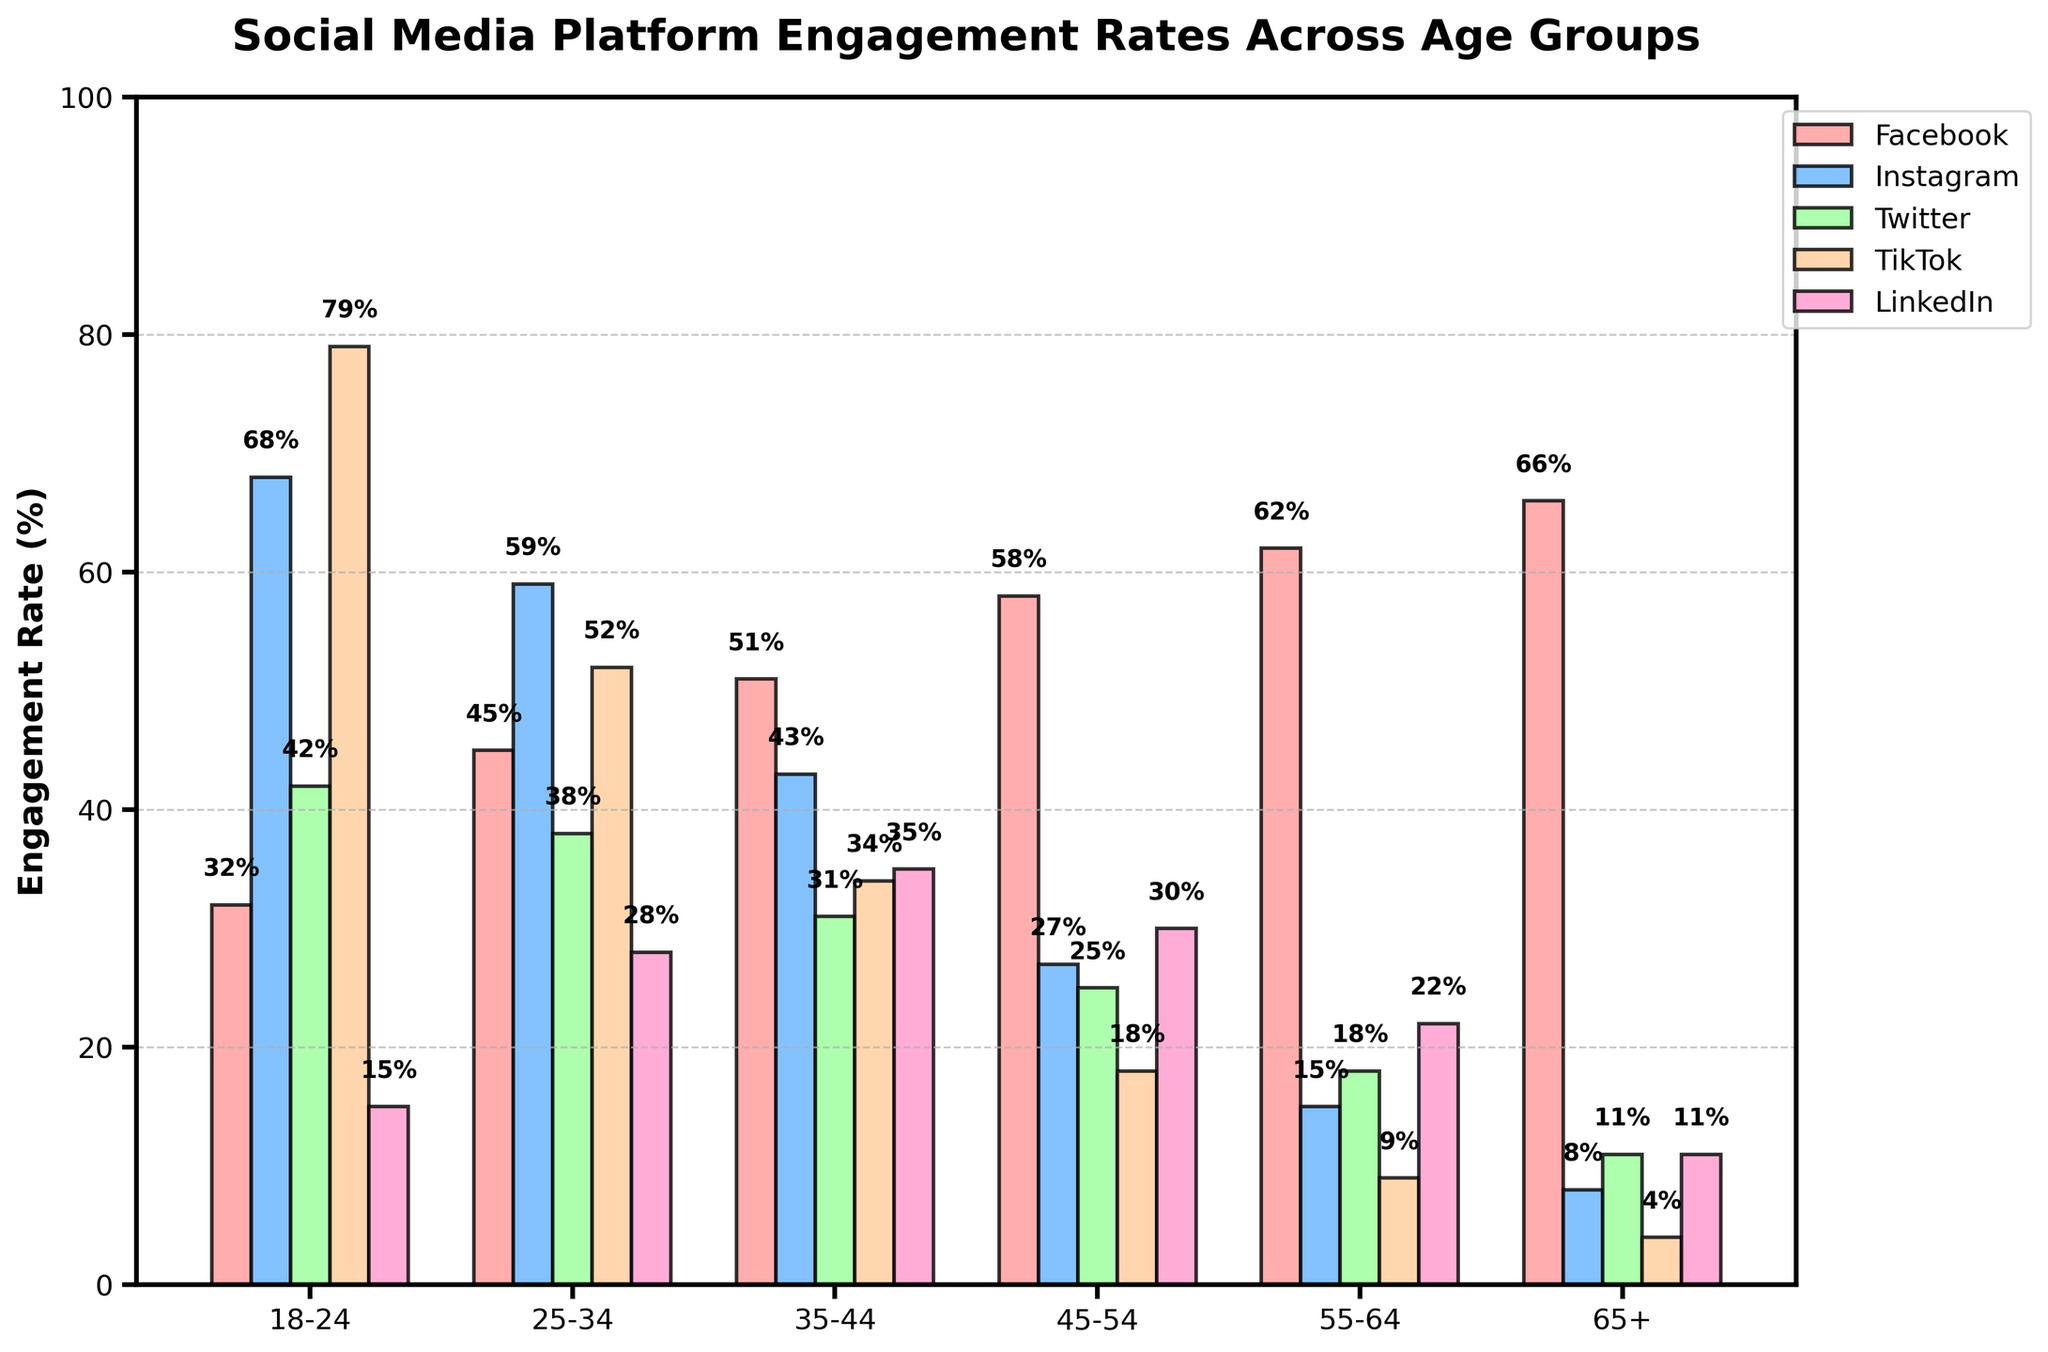What age group has the highest engagement rate on Facebook? The highest bar for Facebook corresponds to the age group 65+, with an engagement rate of 66%.
Answer: 65+ Which social media platform has the lowest engagement rate for the age group 18-24? By looking at the bars for the age group 18-24, LinkedIn has the lowest engagement rate with 15%.
Answer: LinkedIn How much higher is the engagement rate for Instagram than Twitter in the 18-24 age group? The engagement rate for Instagram is 68%, while for Twitter it is 42%. The difference is 68% - 42% = 26%.
Answer: 26% Which age group shows the highest engagement rate on LinkedIn, and what is that rate? The age group with the highest bar for LinkedIn is 35-44, with an engagement rate of 35%.
Answer: 35-44, 35% What's the average engagement rate on TikTok across all age groups? To find the average: (79% + 52% + 34% + 18% + 9% + 4%) / 6 = 32.67%.
Answer: 32.67% For the age group 55-64, which two platforms have the closest engagement rates, and what are those rates? For 55-64, Facebook is 62%, Instagram 15%, Twitter 18%, TikTok 9%, LinkedIn 22%. The closest are Instagram and Twitter (15% and 18%), difference is 3%.
Answer: Instagram and Twitter, 15% and 18% Is the engagement rate for TikTok higher in the 18-24 group or the 25-34 group, and by how much? For the 18-24 group, TikTok has 79%, while the 25-34 group has 52%. The difference is 79% - 52% = 27%.
Answer: 18-24, 27% Rank the social media platforms by engagement rate for the age group 45-54. For 45-54: Facebook 58%, Instagram 27%, Twitter 25%, TikTok 18%, LinkedIn 30%. Ranking from highest to lowest: Facebook, LinkedIn, Instagram, Twitter, TikTok.
Answer: Facebook, LinkedIn, Instagram, Twitter, TikTok Which age group shows a decreasing trend in engagement rate across all platforms? Observing the bars for all platforms, 18-24 age group shows a decreasing trend in engagement rates from Instagram (68%) to LinkedIn (15%) with no reversals.
Answer: 18-24 Among the platforms Instagram and LinkedIn, which one shows a more consistent engagement rate across all age groups? Instagram varies from 68% to 8%, LinkedIn varies from 35% to 11%. Therefore, LinkedIn shows a more consistent engagement, variance is smaller).
Answer: LinkedIn 